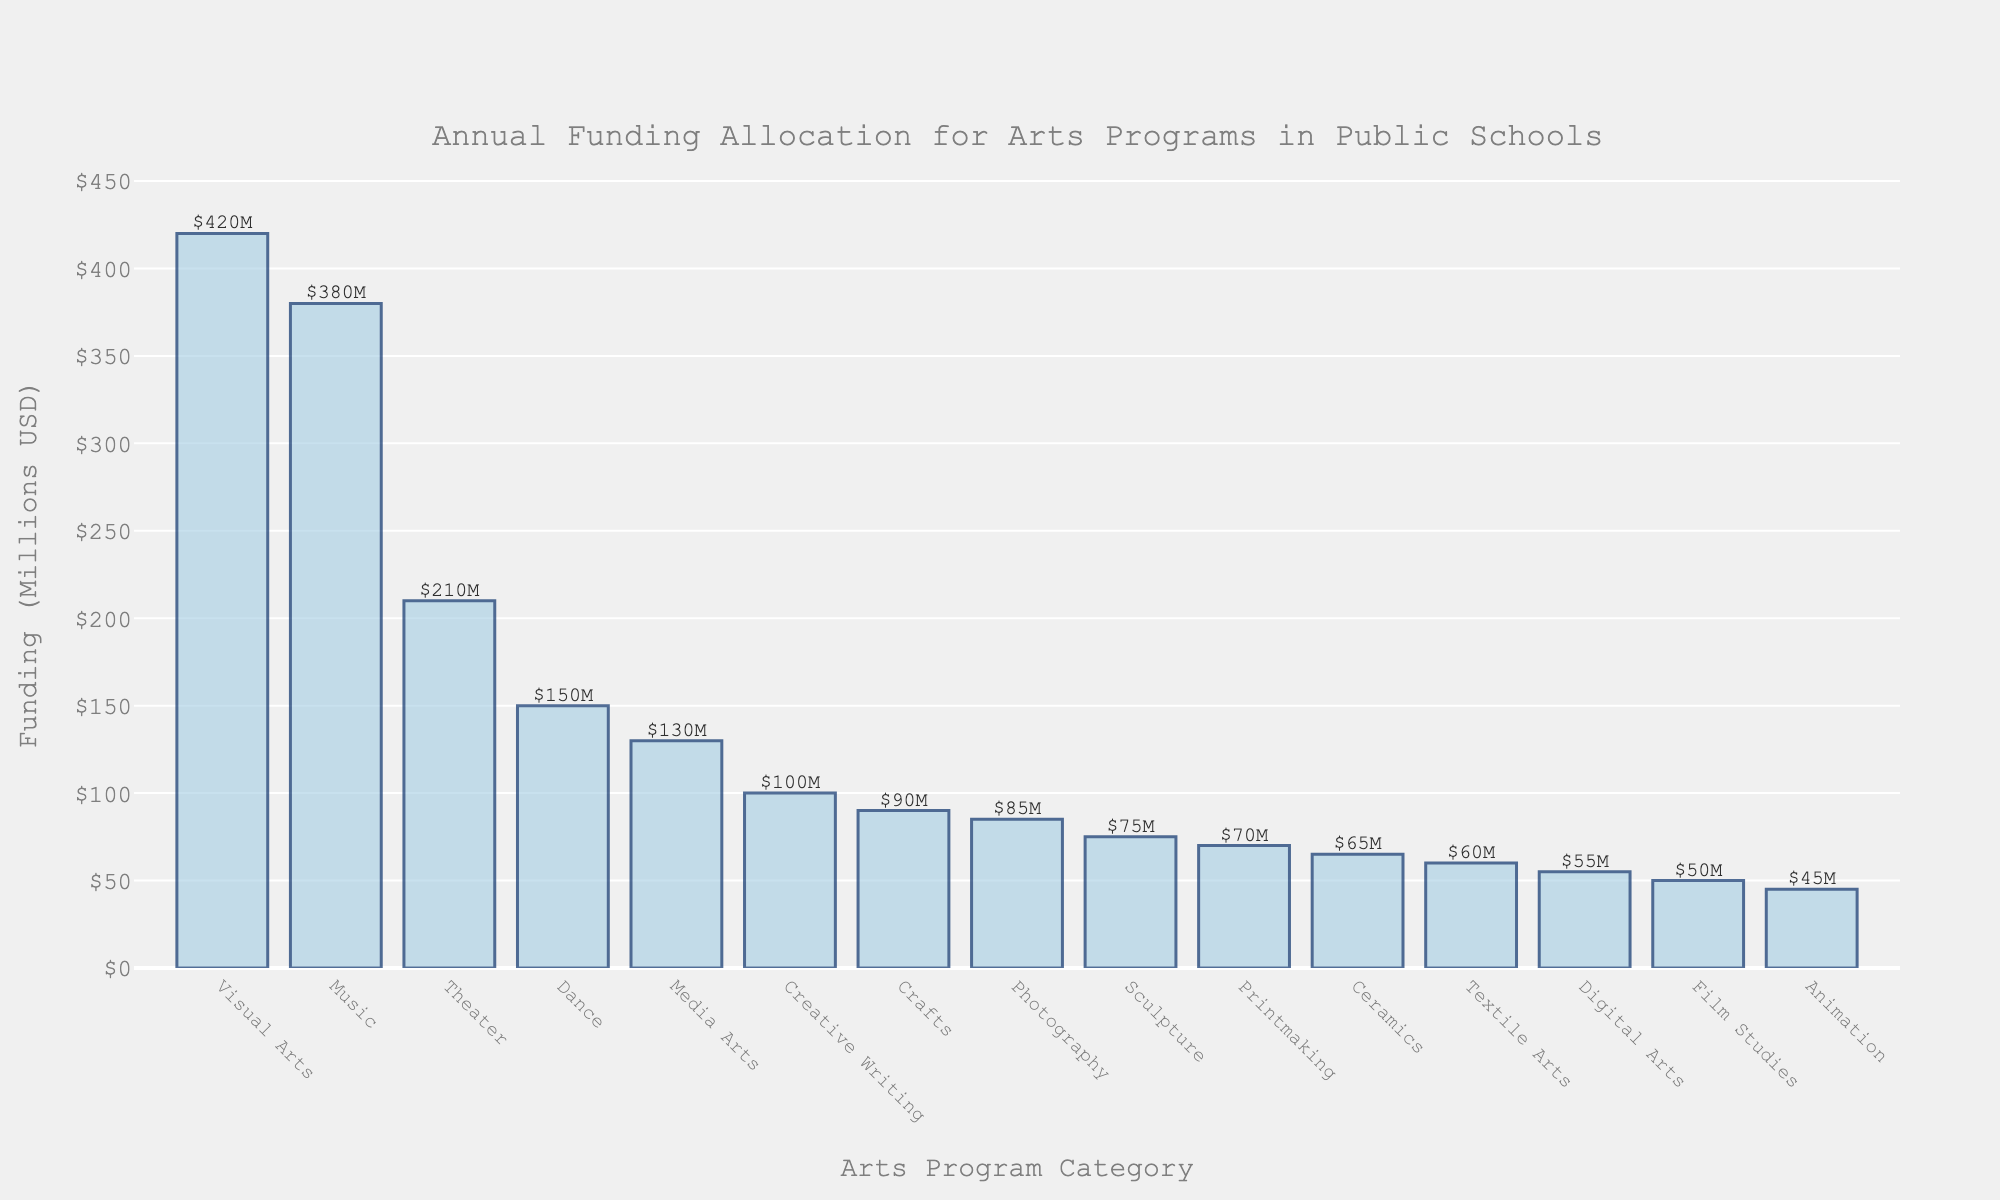How much more funding does Visual Arts receive than Music? First, identify the funding for Visual Arts and Music from the chart, which are $420M and $380M respectively. Subtract the Music funding from the Visual Arts funding: $420M - $380M = $40M
Answer: $40M Which arts program receives the least funding? Look for the shortest bar in the chart, which corresponds to Animation. The funding for Animation is $45M
Answer: Animation What is the total funding allocation for Theater, Dance, and Media Arts combined? Find the funding amounts for Theater, Dance, and Media Arts, which are $210M, $150M, and $130M respectively. Add them together: $210M + $150M + $130M = $490M
Answer: $490M Is the funding for Music greater than both Film Studies and Animation combined? The funding for Music is $380M. The combined funding for Film Studies and Animation is $50M + $45M = $95M. Comparing these values, $380M is greater than $95M
Answer: Yes How many arts programs receive more than $100M in funding? Identify all the bars that represent funding amounts greater than $100M, which are Visual Arts, Music, Theater, Dance, and Media Arts. Count these bars, and you get 5 arts programs
Answer: 5 Do Visual Arts and Music combined receive more funding than all other arts programs together? The combined funding for Visual Arts and Music is $420M + $380M = $800M. Calculate the total funding for all other arts programs: $210M (Theater) + $150M (Dance) + $130M (Media Arts) + $100M (Creative Writing) + $90M (Crafts) + $85M (Photography) + $75M (Sculpture) + $70M (Printmaking) + $65M (Ceramics) + $60M (Textile Arts) + $55M (Digital Arts) + $50M (Film Studies) + $45M (Animation) = $1185M. Comparing these values, $800M is less than $1185M
Answer: No What is the difference in funding between the highest-funded and the lowest-funded arts programs? The highest-funded program is Visual Arts with $420M, and the lowest-funded program is Animation with $45M. Subtract the funding for Animation from the funding for Visual Arts: $420M - $45M = $375M
Answer: $375M Which two arts programs have the closest funding amounts, and what is the difference between them? By examining the bars, the closest funding values are Ceramics ($65M) and Textile Arts ($60M). The difference is $65M - $60M = $5M
Answer: Ceramics and Textile Arts, $5M What is the average funding for Digital Arts, Film Studies, and Animation? Add the funding amounts for Digital Arts, Film Studies, and Animation which are $55M, $50M, and $45M respectively. Sum them up: $55M + $50M + $45M = $150M. The average is $150M / 3 = $50M
Answer: $50M What percentage of the total funding is allocated to Sculpture? First, find the total funding across all categories: $420M + $380M + $210M + $150M + $130M + $100M + $90M + $85M + $75M + $70M + $65M + $60M + $55M + $50M + $45M = $1985M. The funding for Sculpture is $75M. Calculate the percentage: ($75M / $1985M) * 100% ≈ 3.78%
Answer: 3.78% 